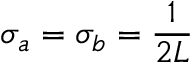Convert formula to latex. <formula><loc_0><loc_0><loc_500><loc_500>\sigma _ { a } = \sigma _ { b } = \frac { 1 } { 2 L }</formula> 